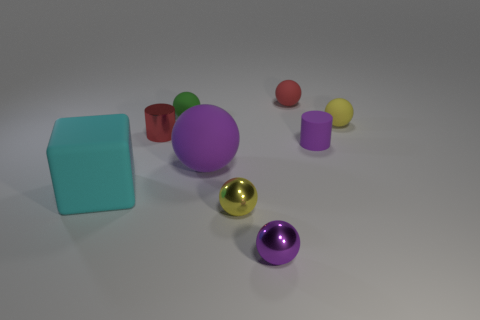If these objects were part of a game, which one do you think would be the most valuable and why? If these objects were part of a game, the golden sphere might be considered the most valuable due to its lustrous, gold-like appearance, which often connotes value and rarity in many cultural contexts. 